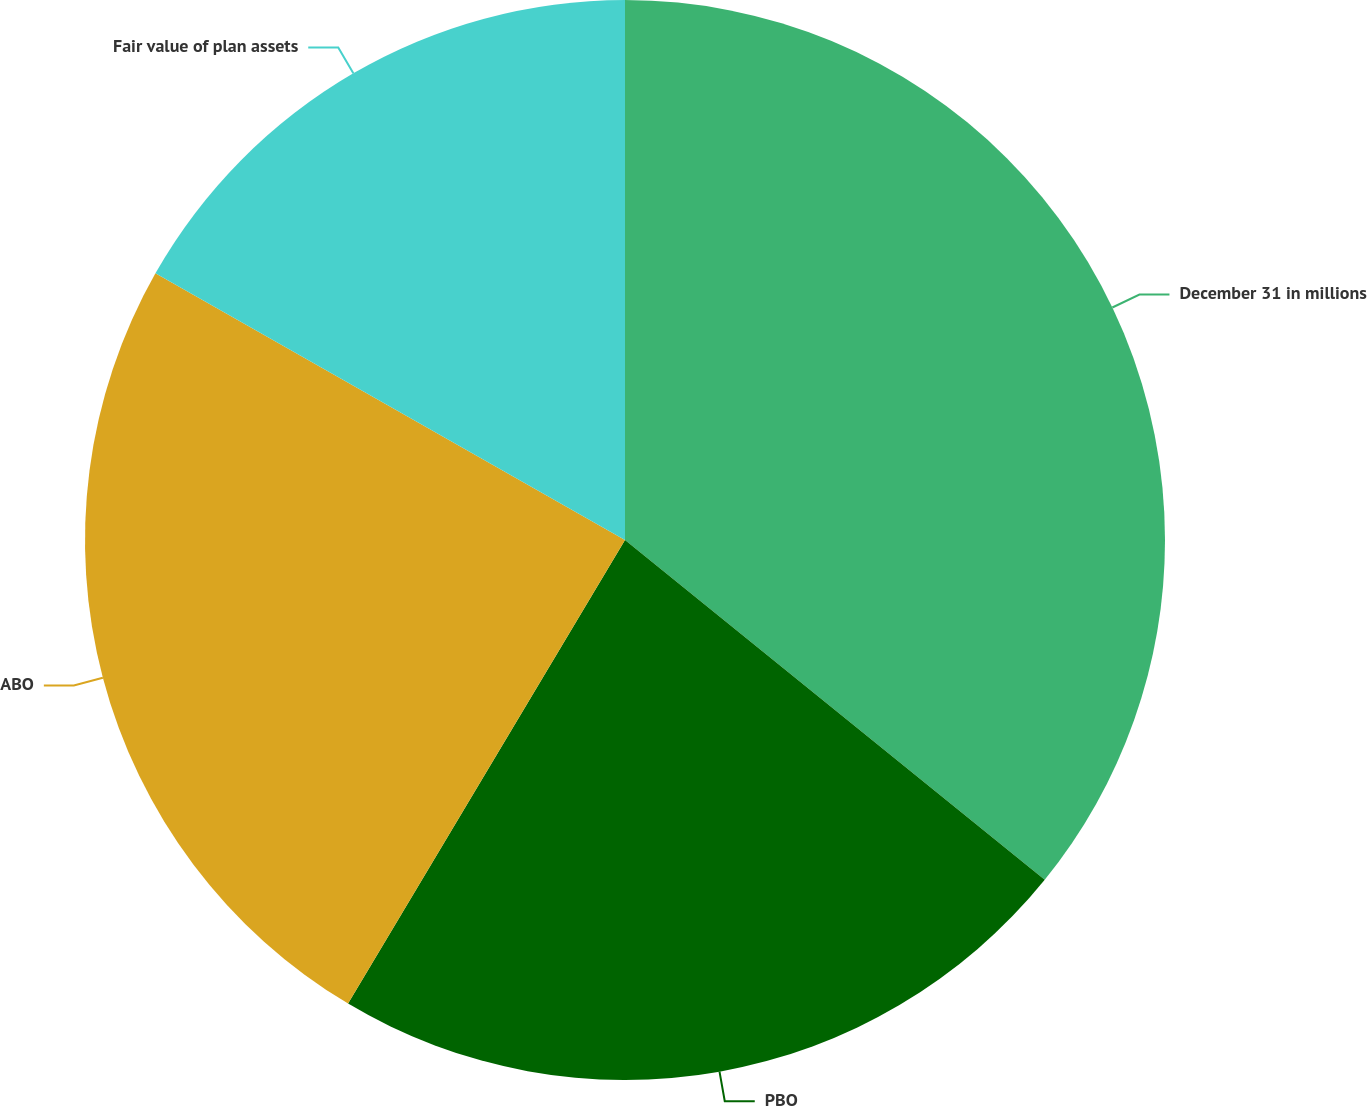Convert chart. <chart><loc_0><loc_0><loc_500><loc_500><pie_chart><fcel>December 31 in millions<fcel>PBO<fcel>ABO<fcel>Fair value of plan assets<nl><fcel>35.83%<fcel>22.74%<fcel>24.65%<fcel>16.78%<nl></chart> 